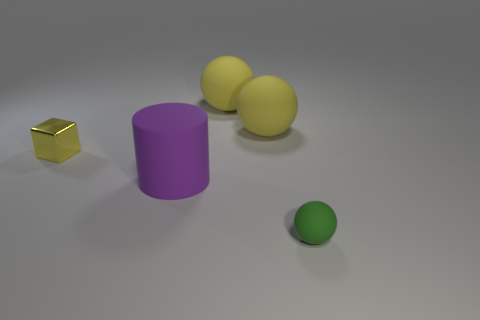Add 1 tiny shiny cubes. How many objects exist? 6 Subtract all balls. How many objects are left? 2 Add 3 metallic cubes. How many metallic cubes exist? 4 Subtract 0 red cylinders. How many objects are left? 5 Subtract all green things. Subtract all small yellow metal cubes. How many objects are left? 3 Add 3 small metal blocks. How many small metal blocks are left? 4 